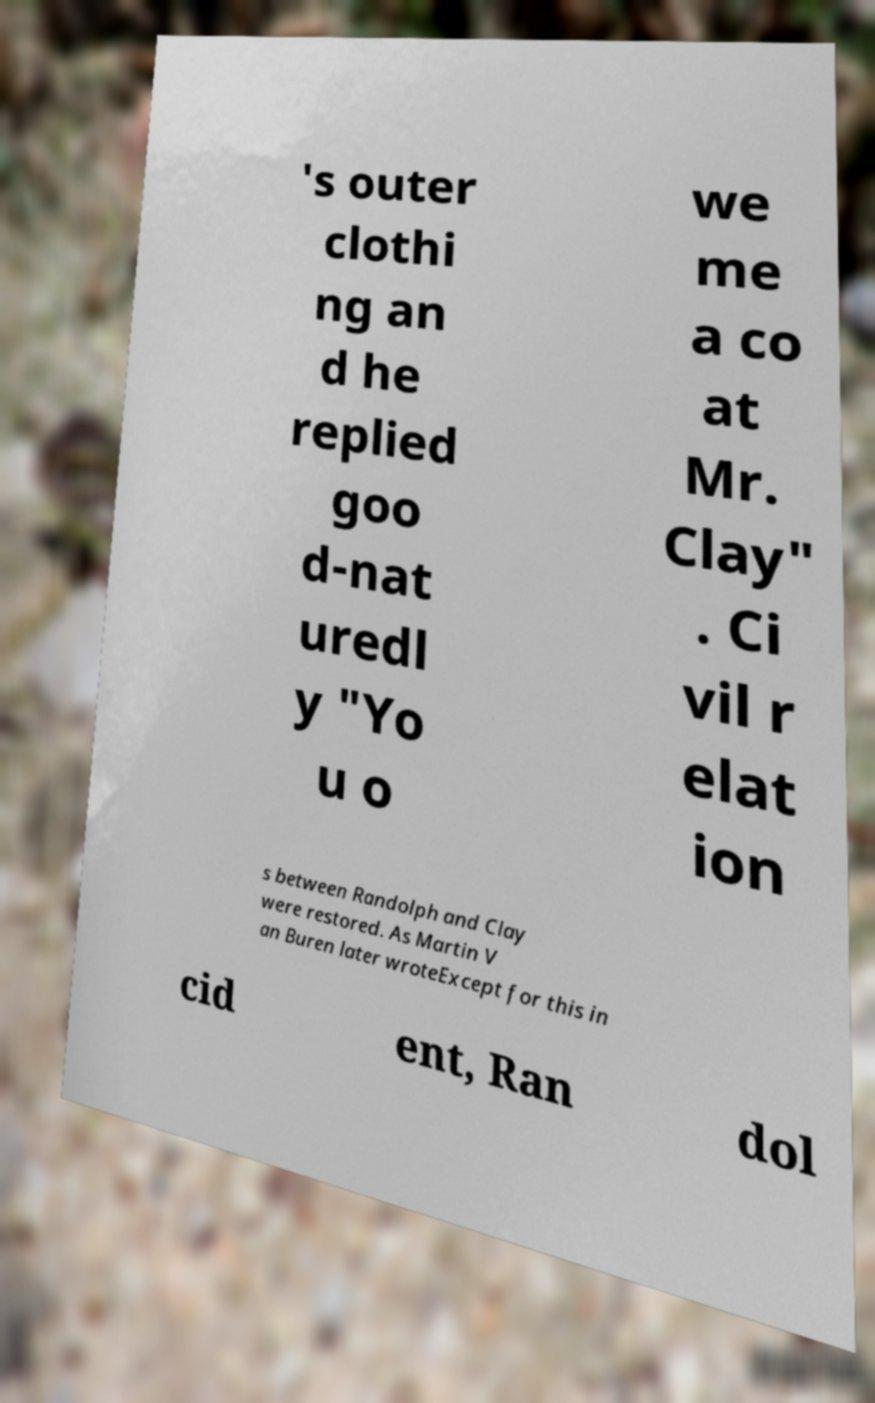Could you extract and type out the text from this image? 's outer clothi ng an d he replied goo d-nat uredl y "Yo u o we me a co at Mr. Clay" . Ci vil r elat ion s between Randolph and Clay were restored. As Martin V an Buren later wroteExcept for this in cid ent, Ran dol 